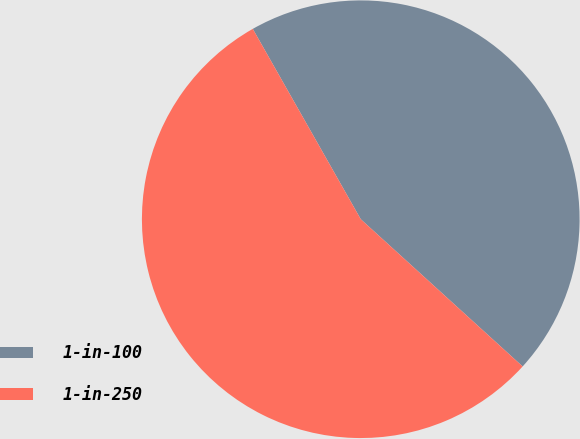<chart> <loc_0><loc_0><loc_500><loc_500><pie_chart><fcel>1-in-100<fcel>1-in-250<nl><fcel>44.96%<fcel>55.04%<nl></chart> 